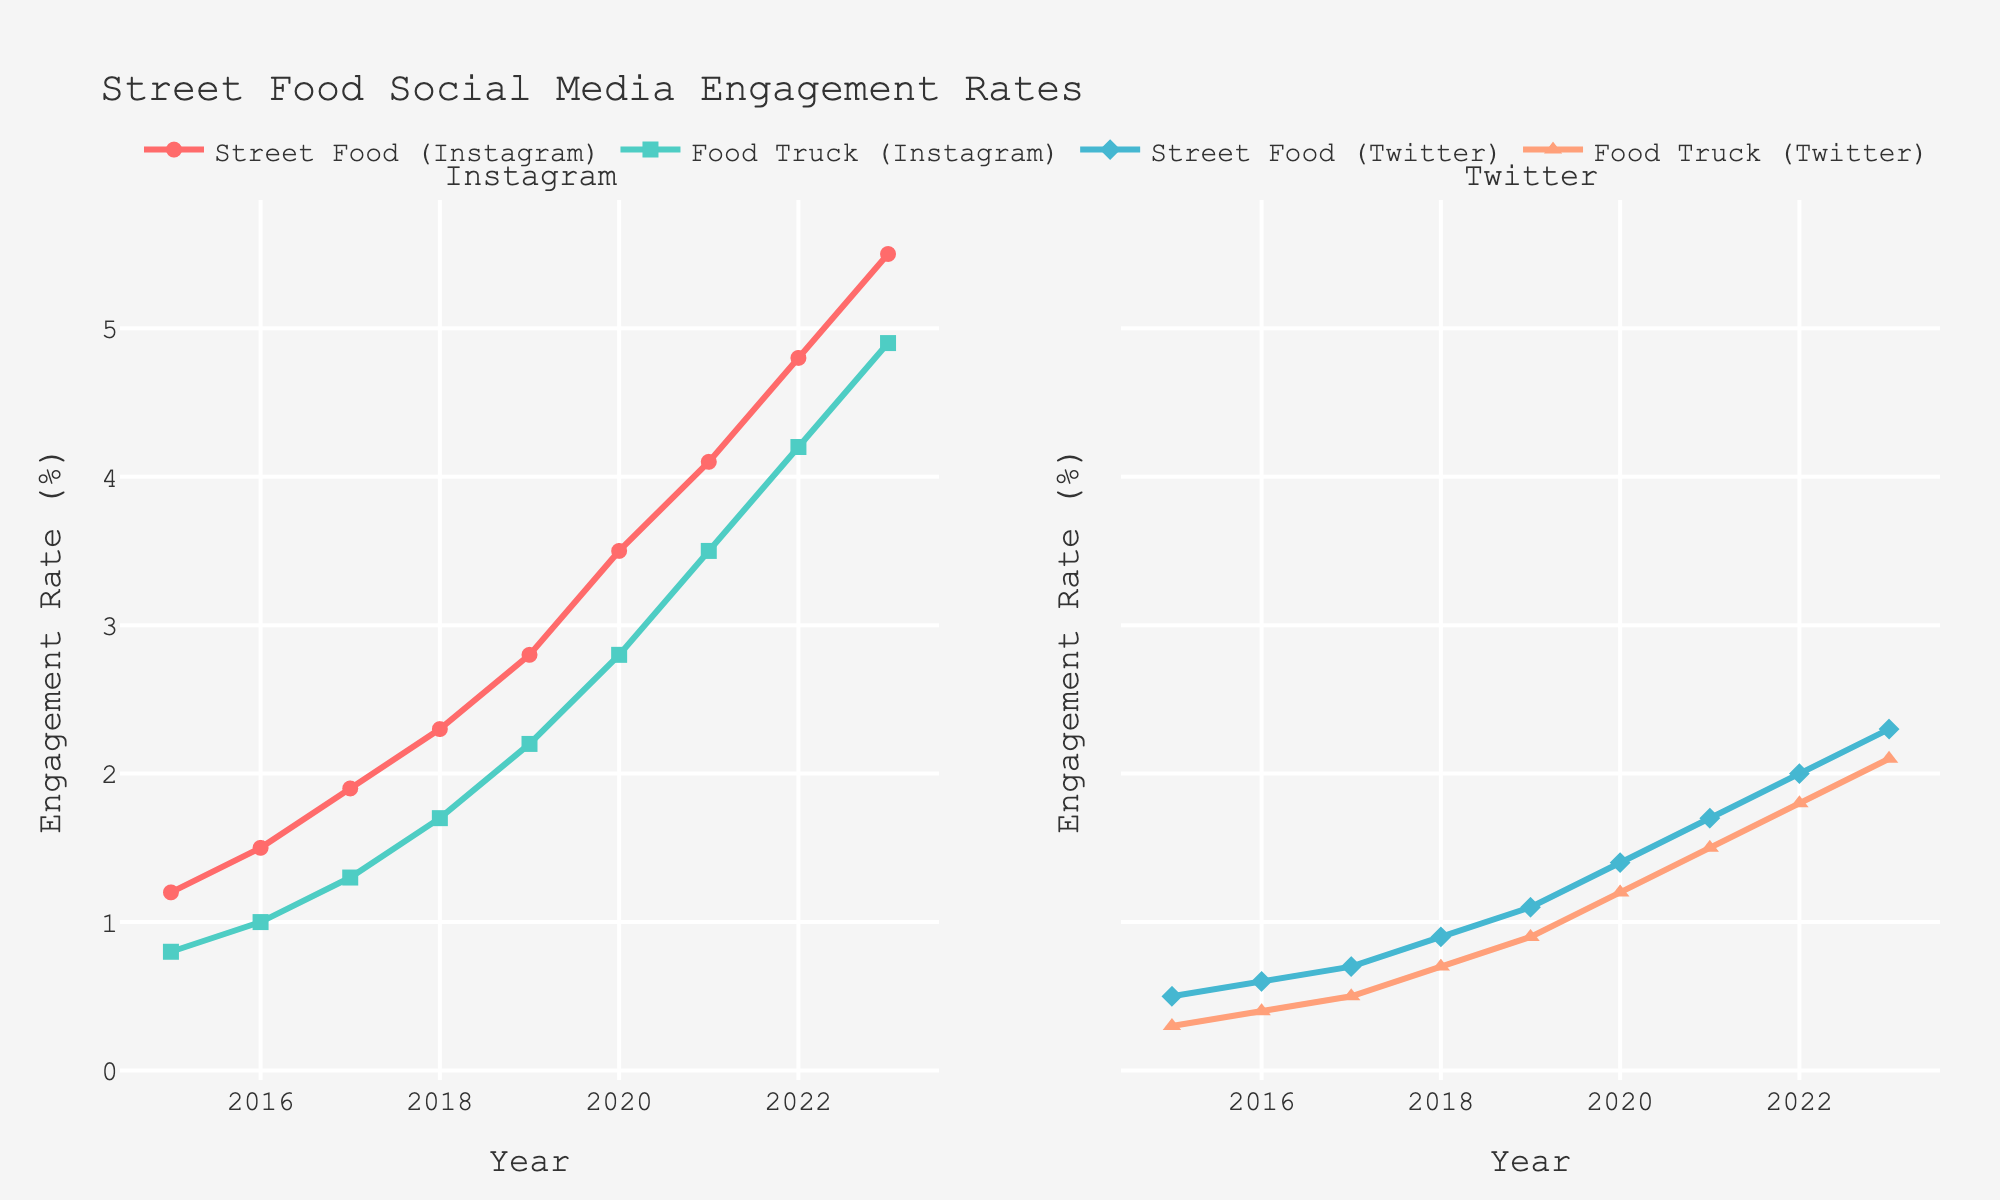What's the general trend of Instagram engagement rates for street food hashtags between 2015 and 2023? To identify the general trend, look at how the line representing Instagram Street Food engagement rates changes over time. It starts at 1.2% in 2015 and rises steadily to 5.5% in 2023. This indicates a consistent upward trend.
Answer: Upward trend Between Instagram and Twitter, which platform had higher engagement rates for street food hashtags in 2020? To answer this, look at the engagement rates for Street Food on both platforms in the year 2020. Instagram Street Food had an engagement rate of 3.5%, while Twitter Street Food had 1.4%.
Answer: Instagram In which year did Twitter Food Truck engagement rates surpass 1% for the first time? Follow the Twitter Food Truck engagement rate line. The engagement rate surpasses 1% in the year 2019 when it reached 1.1%.
Answer: 2019 By how much did Instagram Food Truck engagement rates increase from 2017 to 2019? Check the Instagram Food Truck engagement rates for the years 2017 and 2019. In 2017, it was 1.3%, and in 2019, it was 2.2%. The increase is 2.2% - 1.3% = 0.9%.
Answer: 0.9% Which hashtag had the highest engagement rate on any platform in 2023? Look at the data for 2023 across all hashtags and platforms. Instagram Street Food has the highest engagement rate with 5.5%.
Answer: Instagram Street Food Is the gap between Instagram and Twitter engagement rates for street food hashtags widening or narrowing over time? Compare the gap at multiple time points. The gap increases from 0.7% in 2015 (Instagram 1.2%, Twitter 0.5%) to 3.2% in 2023 (Instagram 5.5%, Twitter 2.3%), indicating it is widening.
Answer: Widening What was the average engagement rate for Food Truck hashtags on Instagram and Twitter combined in 2021? To find the average, sum the Instagram and Twitter engagement rates for Food Truck in 2021, which are 3.5% and 1.5% respectively, then divide by 2. (3.5% + 1.5%)/2 = 2.5%.
Answer: 2.5% Compare the engagement rate growth for Instagram Food Truck and Twitter Food Truck from 2015 to 2023. Which grew more? Calculate the difference in engagement rates for both: Instagram Food Truck grew from 0.8% to 4.9% (4.1% increase), and Twitter Food Truck grew from 0.3% to 2.1% (1.8% increase). Instagram Food Truck grew more.
Answer: Instagram Food Truck What's the ratio of Instagram Street Food engagement rates to Twitter Street Food engagement rates in 2022? Divide the Instagram Street Food engagement rate by the Twitter Street Food engagement rate for 2022. 4.8% / 2.0% = 2.4.
Answer: 2.4 